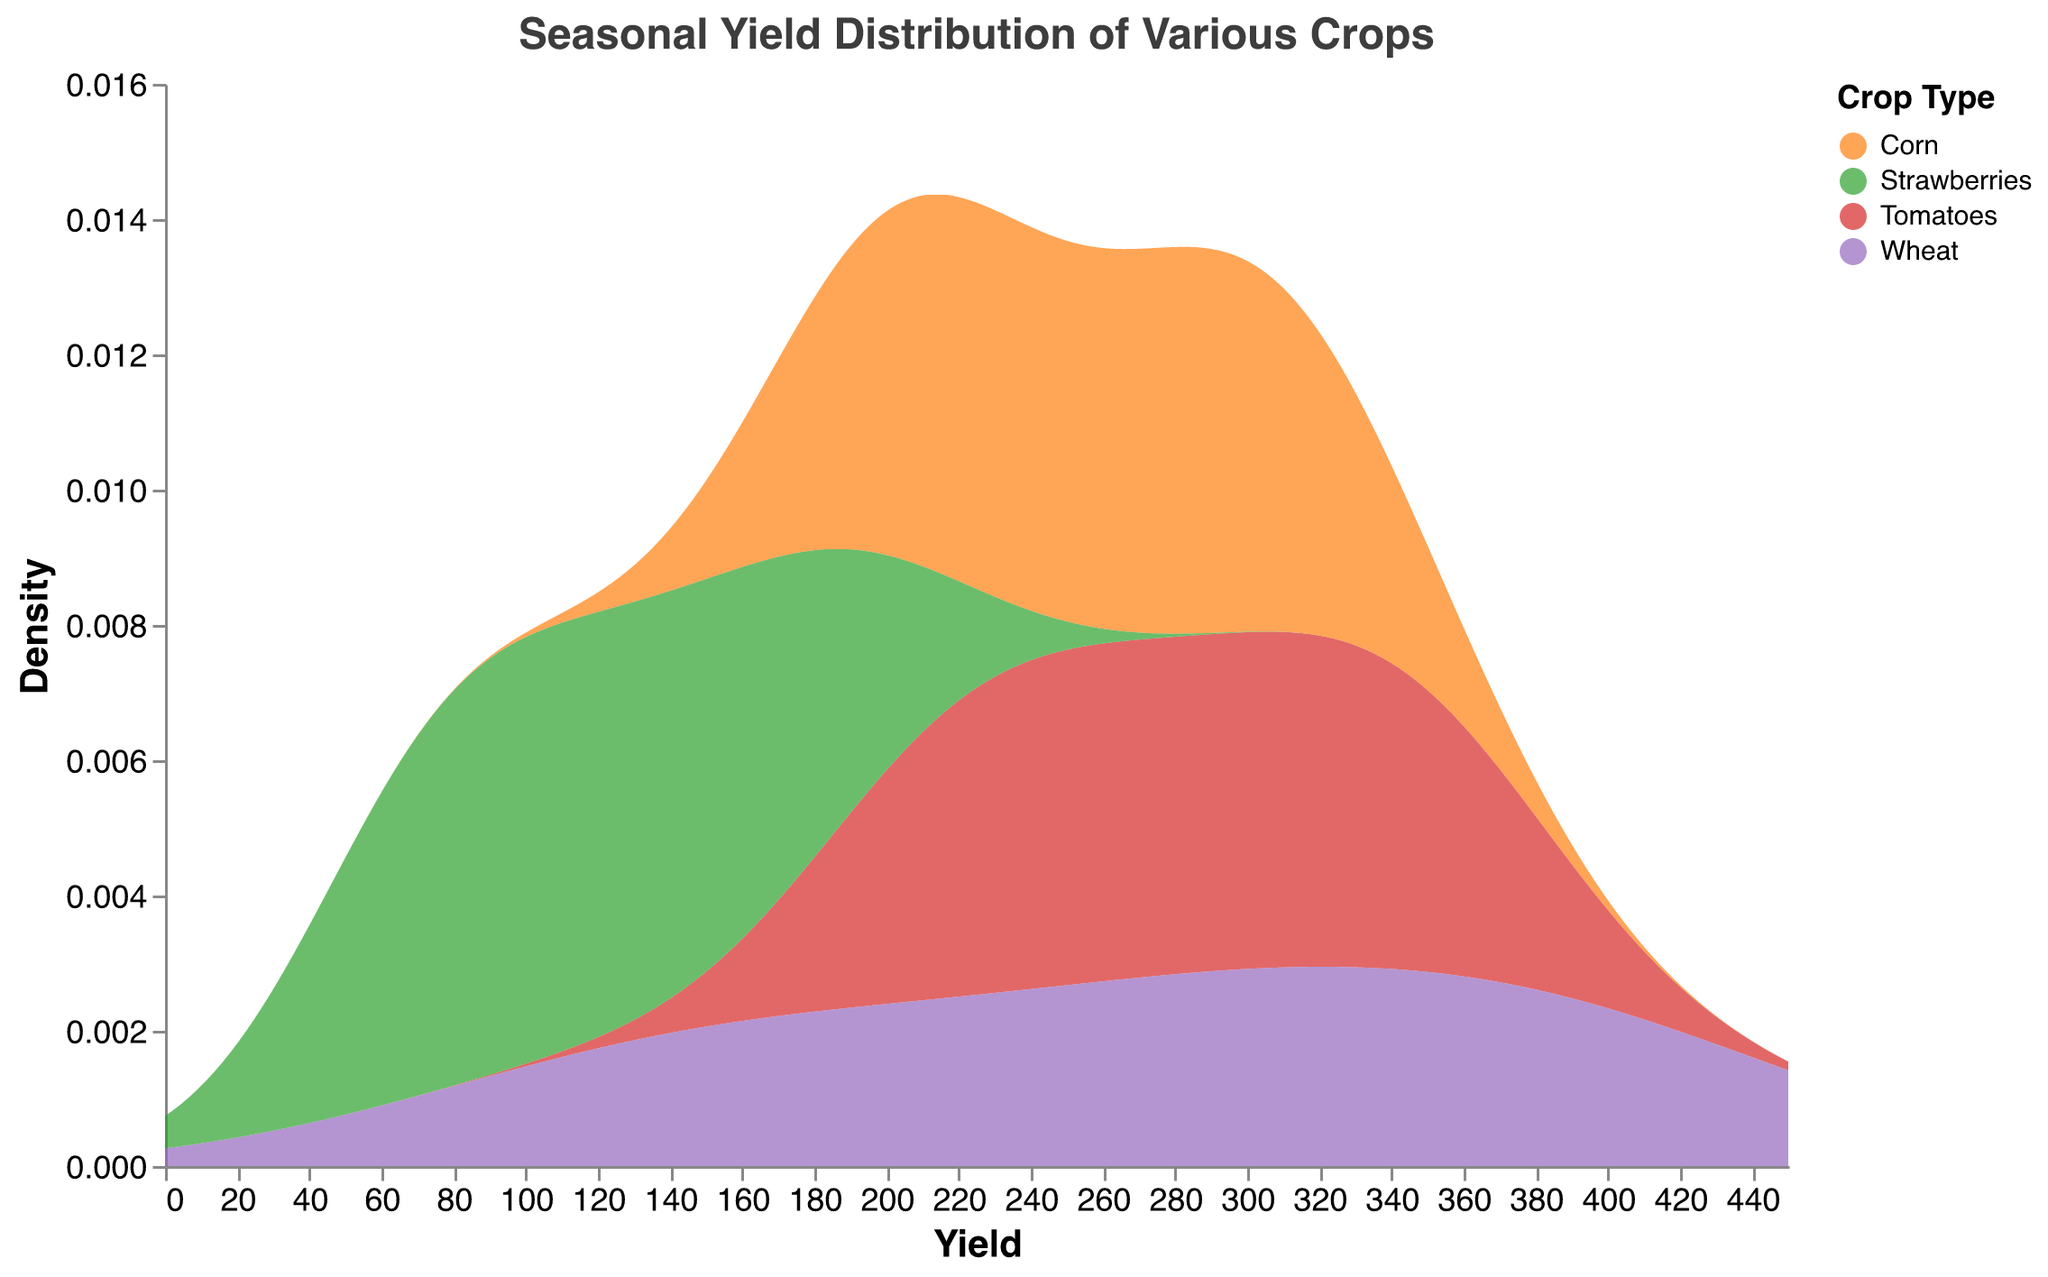What is the title of the figure? The title is located at the top of the figure and usually summarizes the main subject of the plot. In this case, the title states "Seasonal Yield Distribution of Various Crops"
Answer: Seasonal Yield Distribution of Various Crops Which crop shows the highest density at the peak yield? To find the crop with the highest density, look for the crop line that reaches the highest point on the y-axis. In the figure, the "Wheat" density curve reaches the highest point.
Answer: Wheat What is the yield range covered by strawberries? The density plot shows the extent of the yield values on the x-axis for strawberries. The line extends approximately from 50 to 200.
Answer: 50-200 Which crop has the most consistent yield throughout the year? A consistent yield would be indicated by a narrower, taller density plot, implying less variation over the yield range. In this figure, "Strawberries" have a relatively consistent yield because their density curve is narrow and tall.
Answer: Strawberries During which month do tomatoes have the highest yield? The figure does not show exact months, but we can use the underlying data: Tomatoes have the highest yield in August with a value of 370.
Answer: August What is the approximate yield value at which corn's density is highest? Identify the peak of the corn's density curve, then refer to the corresponding x-axis (yield). The peak lies roughly around a yield of 290-300.
Answer: 290-300 Compare the peak yield densities of wheat and corn. Which one is higher? Find the peaks of the density plots for both wheat and corn and compare their heights. Wheat's peak density is higher than corn's.
Answer: Wheat Can you determine the crop with the widest yield distribution? The crop with the widest yield distribution will have the broadest density plot along the x-axis. Wheat demonstrates the widest distribution, ranging from about 100 to 420.
Answer: Wheat What is the yield value range where tomatoes and corn densities overlap significantly? Look at where the density plots of tomatoes and corn intersect or come close together. This region is approximately between 200 and 350.
Answer: 200-350 